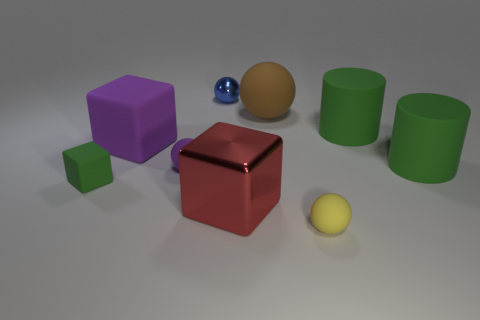How many things are either metal things left of the big shiny object or yellow objects?
Give a very brief answer. 2. There is a metal ball; is its color the same as the shiny thing that is in front of the large purple block?
Ensure brevity in your answer.  No. Are there any other things that have the same size as the blue object?
Ensure brevity in your answer.  Yes. There is a block that is in front of the green rubber object left of the yellow ball; how big is it?
Your answer should be very brief. Large. What number of objects are green matte cylinders or tiny balls that are behind the big purple cube?
Keep it short and to the point. 3. There is a tiny thing that is right of the brown matte thing; is it the same shape as the red thing?
Give a very brief answer. No. There is a big green thing that is behind the large cube to the left of the big shiny block; how many tiny yellow matte balls are to the right of it?
Keep it short and to the point. 0. Is there any other thing that has the same shape as the red shiny thing?
Your response must be concise. Yes. How many things are large green matte objects or matte objects?
Offer a very short reply. 7. There is a large purple thing; is its shape the same as the tiny object that is right of the red object?
Keep it short and to the point. No. 